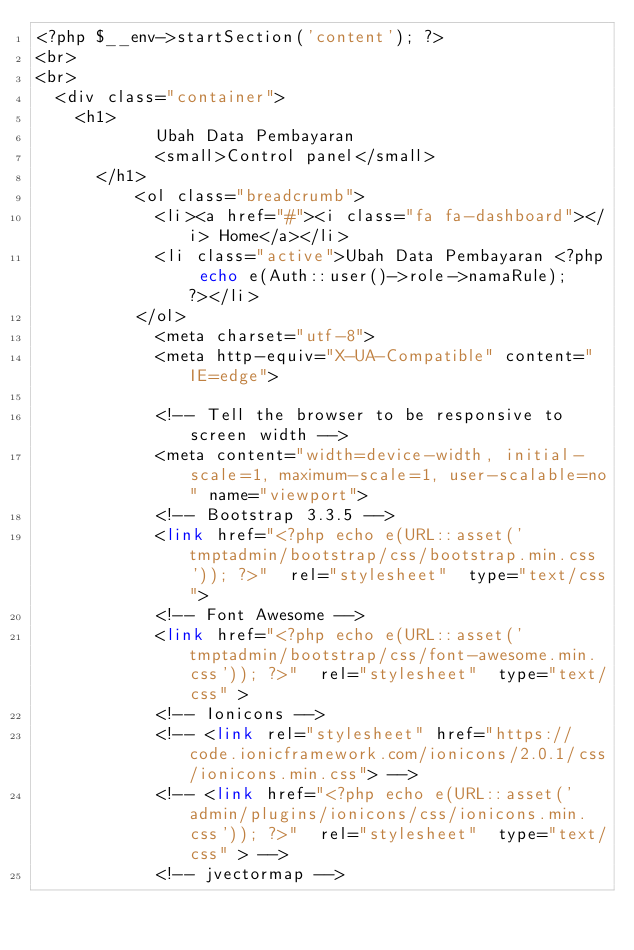<code> <loc_0><loc_0><loc_500><loc_500><_PHP_><?php $__env->startSection('content'); ?>
<br>
<br>
	<div class="container">	
		<h1>
            Ubah Data Pembayaran
            <small>Control panel</small>
	    </h1>
		      <ol class="breadcrumb">
		        <li><a href="#"><i class="fa fa-dashboard"></i> Home</a></li>
		        <li class="active">Ubah Data Pembayaran <?php echo e(Auth::user()->role->namaRule); ?></li>
		      </ol>
				    <meta charset="utf-8">
				    <meta http-equiv="X-UA-Compatible" content="IE=edge">
				    
				    <!-- Tell the browser to be responsive to screen width -->
				    <meta content="width=device-width, initial-scale=1, maximum-scale=1, user-scalable=no" name="viewport">
				    <!-- Bootstrap 3.3.5 -->
				    <link href="<?php echo e(URL::asset('tmptadmin/bootstrap/css/bootstrap.min.css')); ?>"  rel="stylesheet"  type="text/css">
				    <!-- Font Awesome -->
				    <link href="<?php echo e(URL::asset('tmptadmin/bootstrap/css/font-awesome.min.css')); ?>"  rel="stylesheet"  type="text/css" >
				    <!-- Ionicons -->
				    <!-- <link rel="stylesheet" href="https://code.ionicframework.com/ionicons/2.0.1/css/ionicons.min.css"> -->
				    <!-- <link href="<?php echo e(URL::asset('admin/plugins/ionicons/css/ionicons.min.css')); ?>"  rel="stylesheet"  type="text/css" > -->
				    <!-- jvectormap -->
				    </code> 